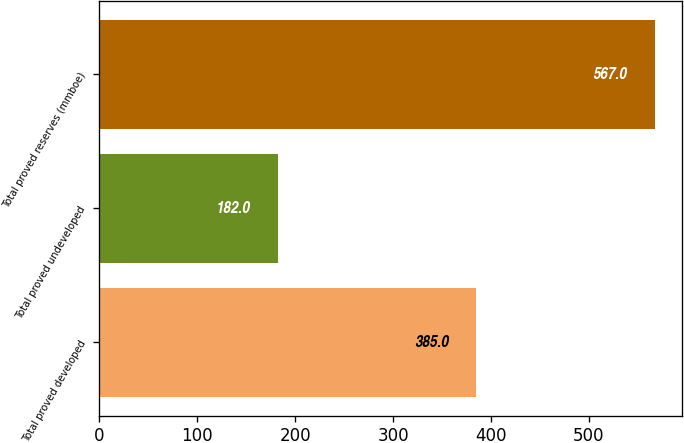Convert chart to OTSL. <chart><loc_0><loc_0><loc_500><loc_500><bar_chart><fcel>Total proved developed<fcel>Total proved undeveloped<fcel>Total proved reserves (mmboe)<nl><fcel>385<fcel>182<fcel>567<nl></chart> 